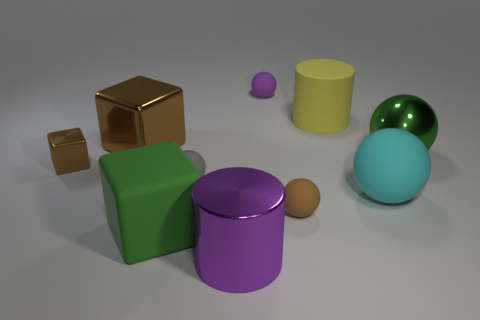Can you describe the texture and finish of the objects? Certainly! The objects in the image have various textures and finishes. The cubes appear to have a matte, slightly textured finish, while the cylinders are shiny and reflective. The spherical objects also have a high-gloss finish, suggestive of a smooth surface. 